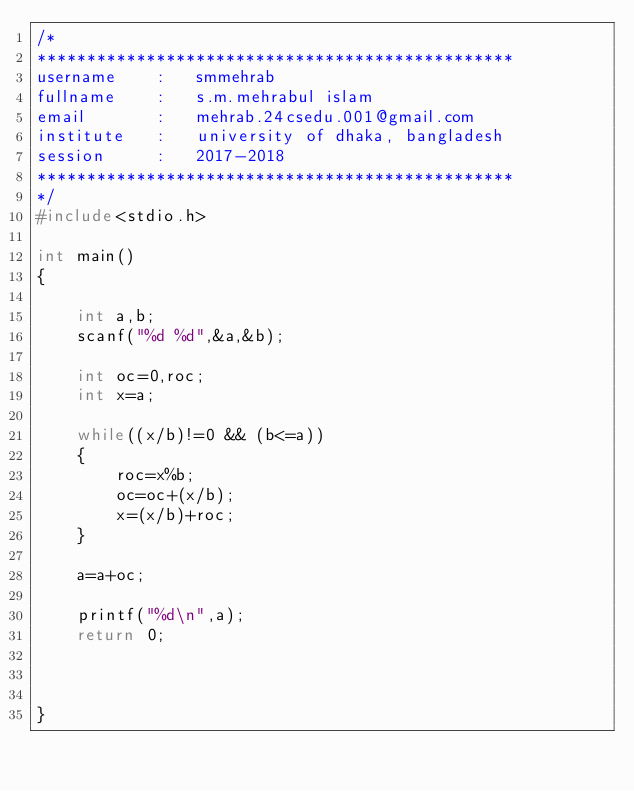<code> <loc_0><loc_0><loc_500><loc_500><_C_>/*
************************************************
username    :   smmehrab
fullname    :   s.m.mehrabul islam
email       :   mehrab.24csedu.001@gmail.com
institute   :   university of dhaka, bangladesh
session     :   2017-2018
************************************************
*/
#include<stdio.h>

int main()
{

    int a,b;
    scanf("%d %d",&a,&b);

    int oc=0,roc;
    int x=a;

    while((x/b)!=0 && (b<=a))
    {
        roc=x%b;
        oc=oc+(x/b);
        x=(x/b)+roc;
    }

    a=a+oc;

    printf("%d\n",a);
    return 0;



}
</code> 